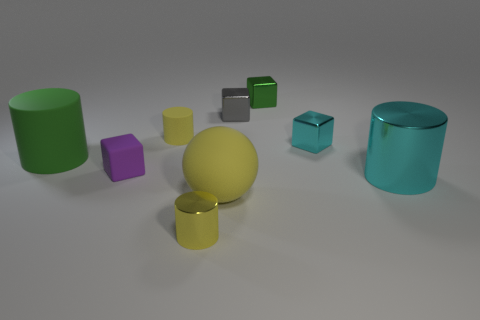Subtract 1 cylinders. How many cylinders are left? 3 Subtract all blue blocks. Subtract all cyan balls. How many blocks are left? 4 Add 1 blue metal cylinders. How many objects exist? 10 Subtract all blocks. How many objects are left? 5 Subtract all blue cylinders. Subtract all green metallic objects. How many objects are left? 8 Add 1 tiny gray things. How many tiny gray things are left? 2 Add 5 yellow matte cylinders. How many yellow matte cylinders exist? 6 Subtract 2 yellow cylinders. How many objects are left? 7 